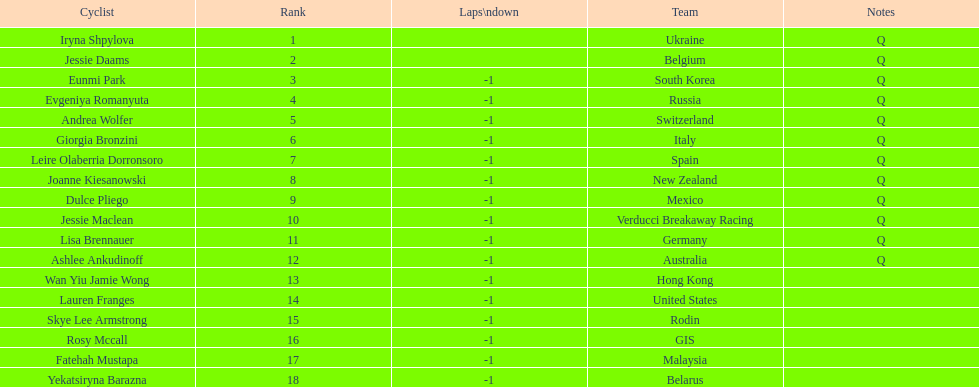Who was the competitor that finished above jessie maclean? Dulce Pliego. 